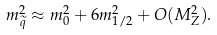Convert formula to latex. <formula><loc_0><loc_0><loc_500><loc_500>m _ { \widetilde { q } } ^ { 2 } \approx m _ { 0 } ^ { 2 } + 6 m _ { 1 / 2 } ^ { 2 } + O ( M _ { Z } ^ { 2 } ) .</formula> 